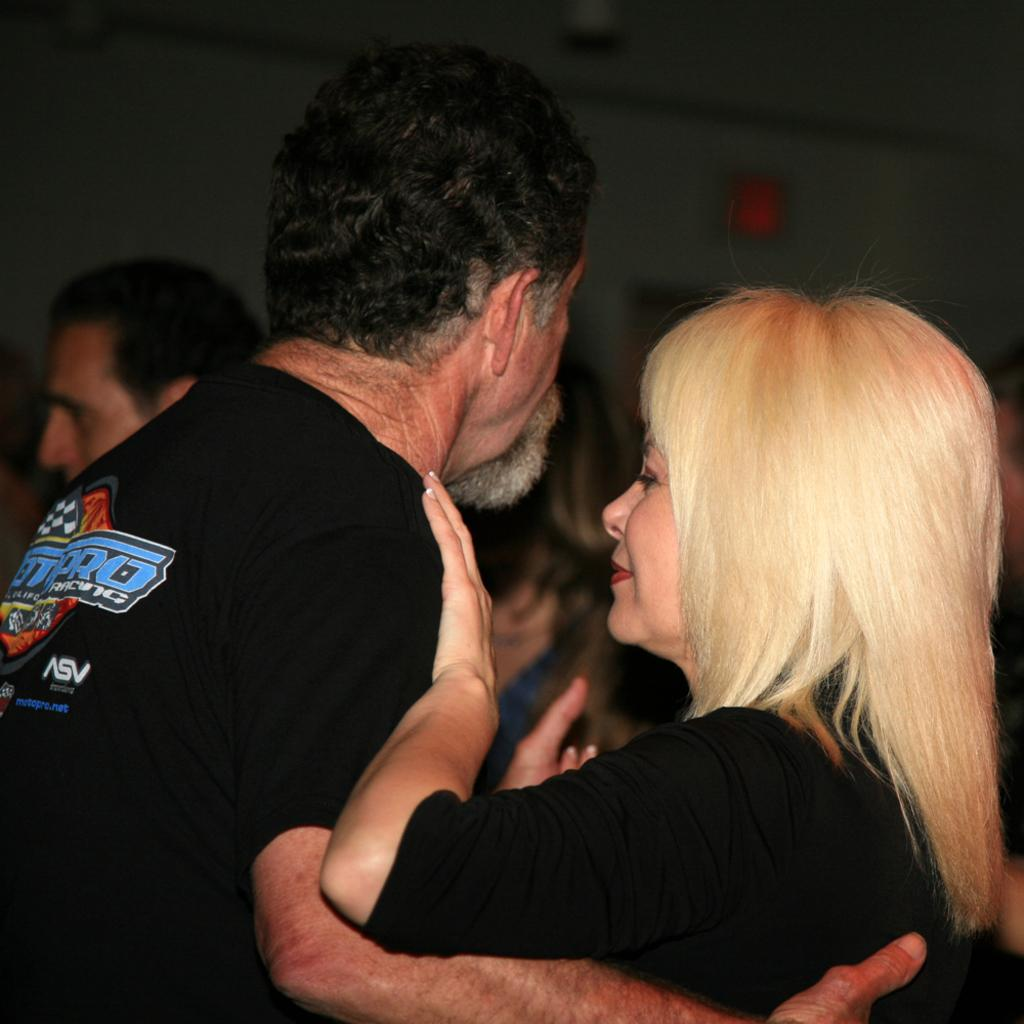<image>
Relay a brief, clear account of the picture shown. A man weraing a black top with racing written on it dances with a blonde woman. 